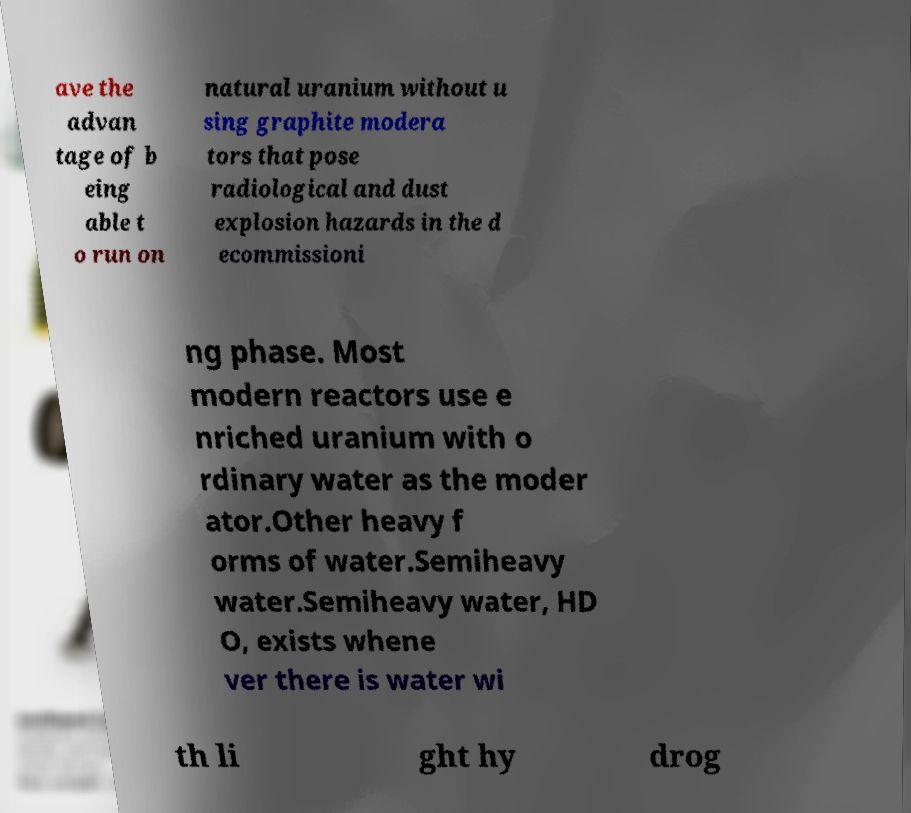I need the written content from this picture converted into text. Can you do that? ave the advan tage of b eing able t o run on natural uranium without u sing graphite modera tors that pose radiological and dust explosion hazards in the d ecommissioni ng phase. Most modern reactors use e nriched uranium with o rdinary water as the moder ator.Other heavy f orms of water.Semiheavy water.Semiheavy water, HD O, exists whene ver there is water wi th li ght hy drog 